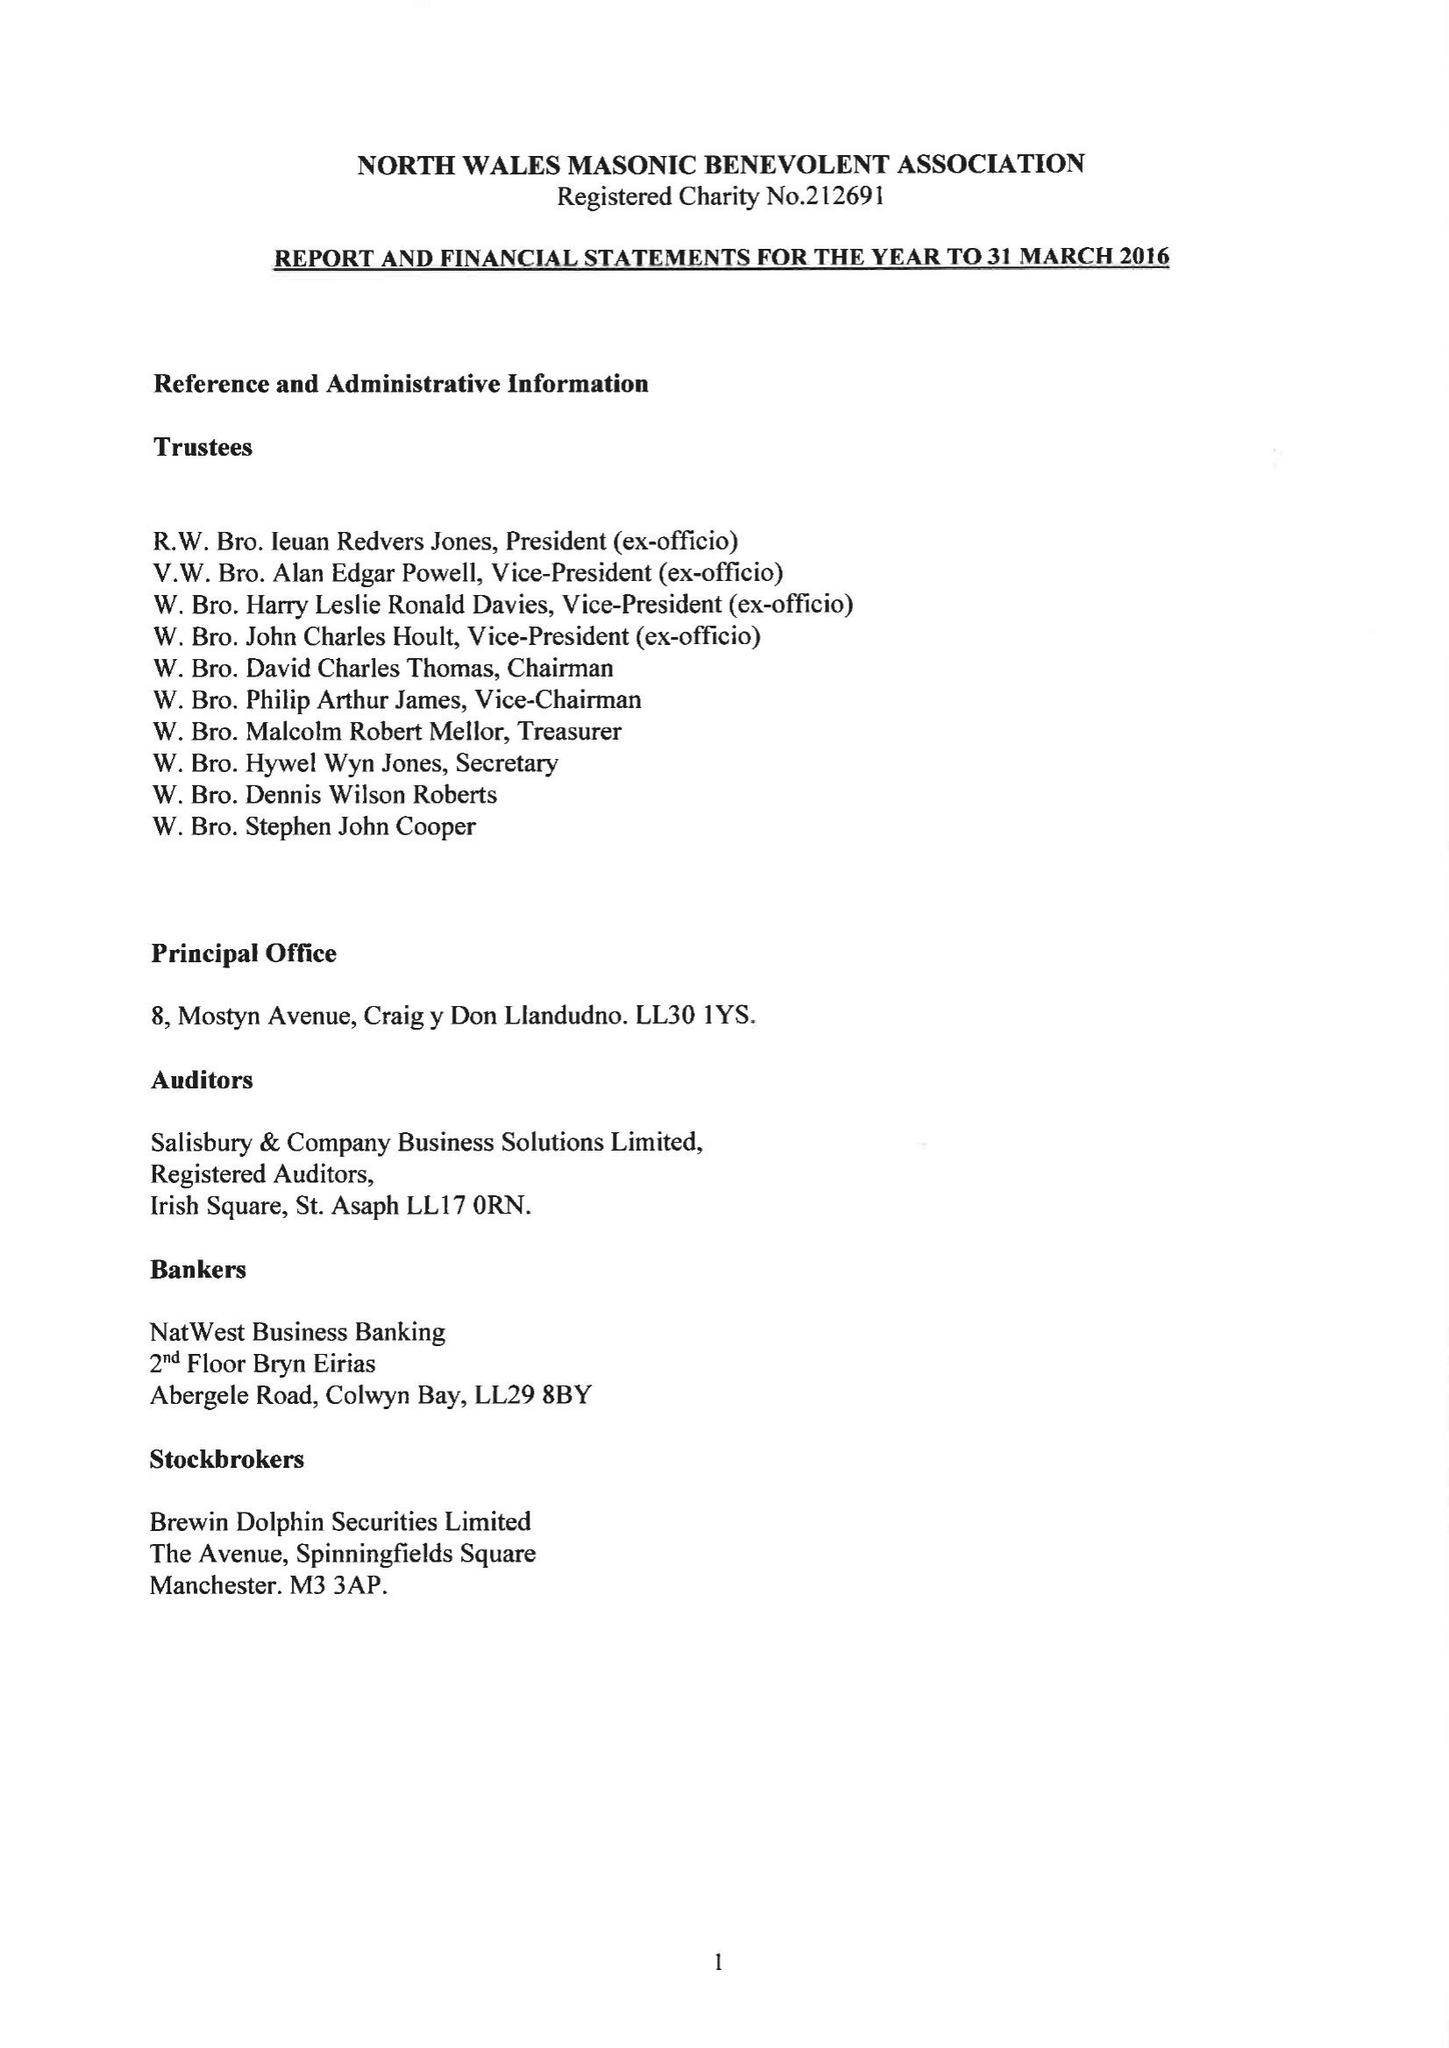What is the value for the address__street_line?
Answer the question using a single word or phrase. None 